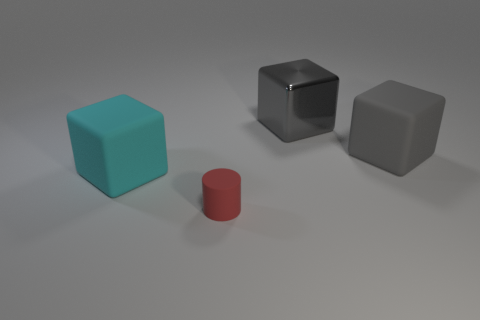Is there anything else that has the same size as the red matte cylinder?
Provide a succinct answer. No. What number of other objects are there of the same size as the gray matte object?
Your response must be concise. 2. Is the matte cylinder the same color as the shiny block?
Keep it short and to the point. No. The thing in front of the rubber block that is on the left side of the red rubber cylinder that is left of the big gray metal object is what color?
Your answer should be compact. Red. How many shiny blocks are behind the thing behind the big gray cube that is in front of the gray metallic block?
Ensure brevity in your answer.  0. Is there anything else of the same color as the big shiny thing?
Keep it short and to the point. Yes. Does the rubber cube that is on the right side of the cyan rubber cube have the same size as the tiny rubber cylinder?
Make the answer very short. No. How many rubber objects are in front of the gray object left of the gray rubber cube?
Offer a terse response. 3. There is a gray thing that is behind the gray block in front of the metallic cube; are there any gray blocks to the right of it?
Your response must be concise. Yes. There is another cyan thing that is the same shape as the big shiny object; what material is it?
Give a very brief answer. Rubber. 